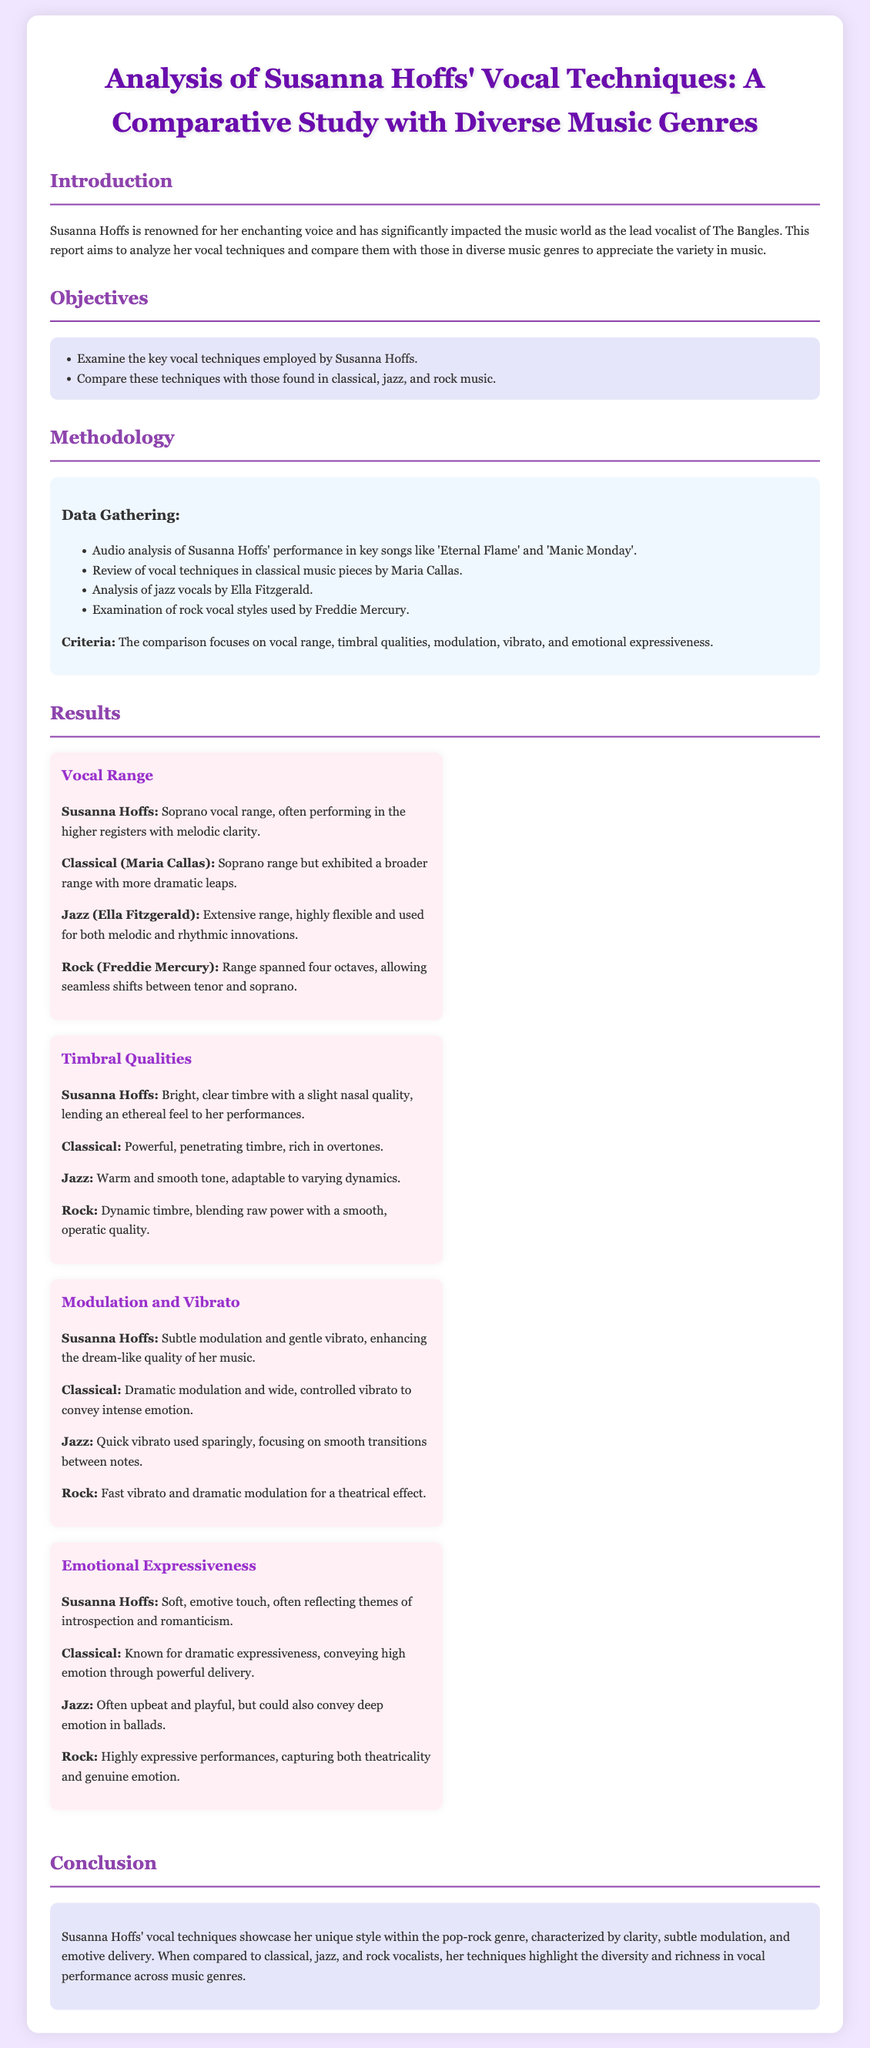What is the title of the lab report? The title is clearly stated at the beginning of the document, summarizing the focus of the analysis.
Answer: Analysis of Susanna Hoffs' Vocal Techniques: A Comparative Study with Diverse Music Genres Who is compared to Susanna Hoffs in the study? The document lists Maria Callas, Ella Fitzgerald, and Freddie Mercury as points of comparison with Hoffs.
Answer: Maria Callas, Ella Fitzgerald, Freddie Mercury What vocal technique does Susanna Hoffs primarily utilize? The document mentions that Hoffs employs a specific vocal range, emphasizing her unique attributes.
Answer: Soprano vocal range What is one method used for data gathering? The document details methods used in the study, focusing on specific song performances for audio analysis.
Answer: Audio analysis of Susanna Hoffs' performance Which genre is NOT mentioned in the vocal comparison? The objectives state the genres compared, so identifying one not included is straightforward.
Answer: Heavy metal What characteristic of Hoffs' timbre is highlighted? The description in the results emphasizes a distinct quality in her vocal sound.
Answer: Bright, clear timbre How does Hoffs' emotional expressiveness compare to classical music? By comparing different genres, insights into emotional delivery are drawn out.
Answer: Softer, less dramatic What is emphasized in the conclusion about Hoffs' style? The conclusion summarizes the findings and characterizes Hoffs’ vocal performance within a broader context.
Answer: Unique style within the pop-rock genre 